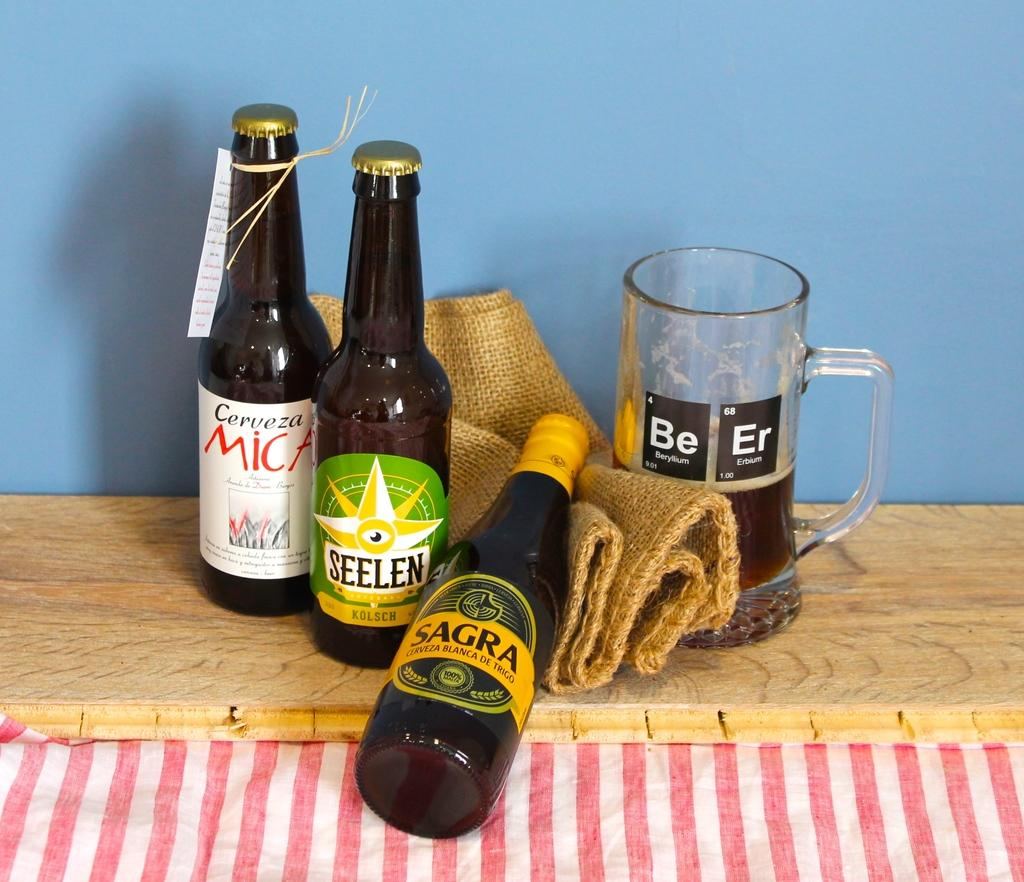Provide a one-sentence caption for the provided image. A bottle of sagra lies on a brown cloth. 